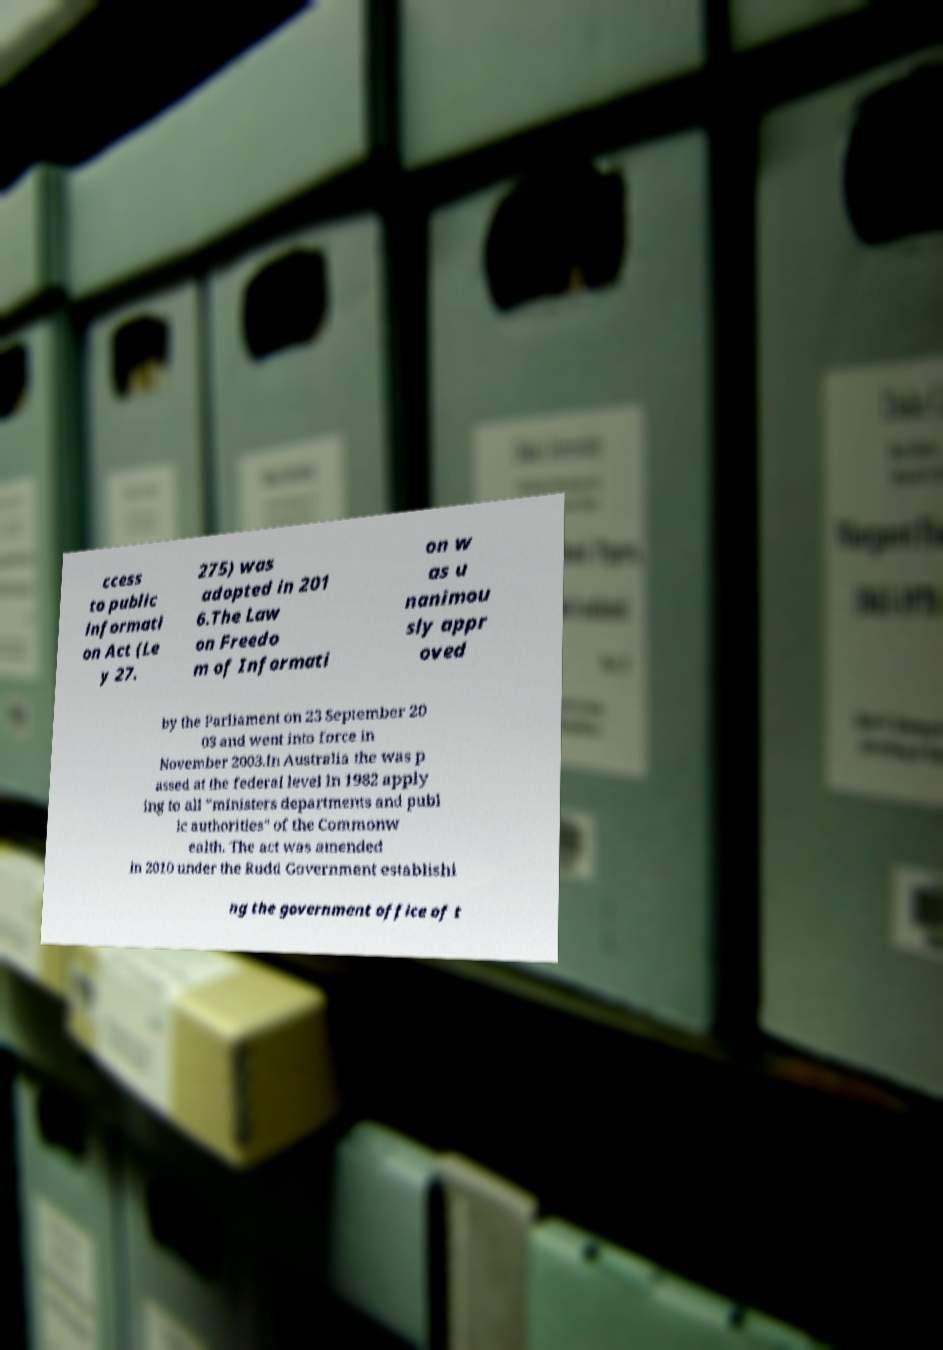For documentation purposes, I need the text within this image transcribed. Could you provide that? ccess to public informati on Act (Le y 27. 275) was adopted in 201 6.The Law on Freedo m of Informati on w as u nanimou sly appr oved by the Parliament on 23 September 20 03 and went into force in November 2003.In Australia the was p assed at the federal level in 1982 apply ing to all "ministers departments and publ ic authorities" of the Commonw ealth. The act was amended in 2010 under the Rudd Government establishi ng the government office of t 